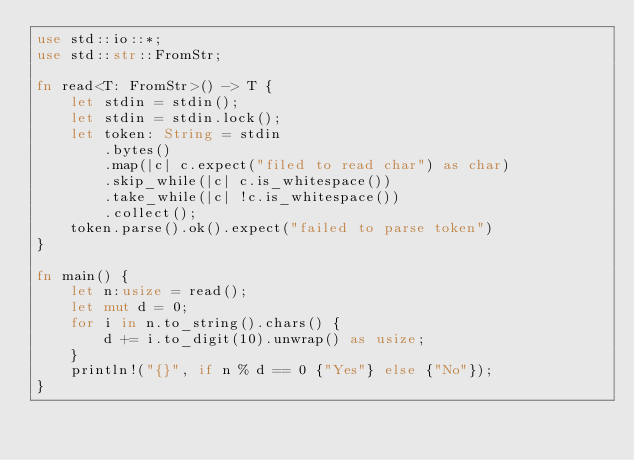Convert code to text. <code><loc_0><loc_0><loc_500><loc_500><_Rust_>use std::io::*;
use std::str::FromStr;

fn read<T: FromStr>() -> T {
    let stdin = stdin();
    let stdin = stdin.lock();
    let token: String = stdin
        .bytes()
        .map(|c| c.expect("filed to read char") as char)
        .skip_while(|c| c.is_whitespace())
        .take_while(|c| !c.is_whitespace())
        .collect();
    token.parse().ok().expect("failed to parse token")
}

fn main() {
    let n:usize = read();
    let mut d = 0;
    for i in n.to_string().chars() {
        d += i.to_digit(10).unwrap() as usize;
    }
    println!("{}", if n % d == 0 {"Yes"} else {"No"});
}</code> 